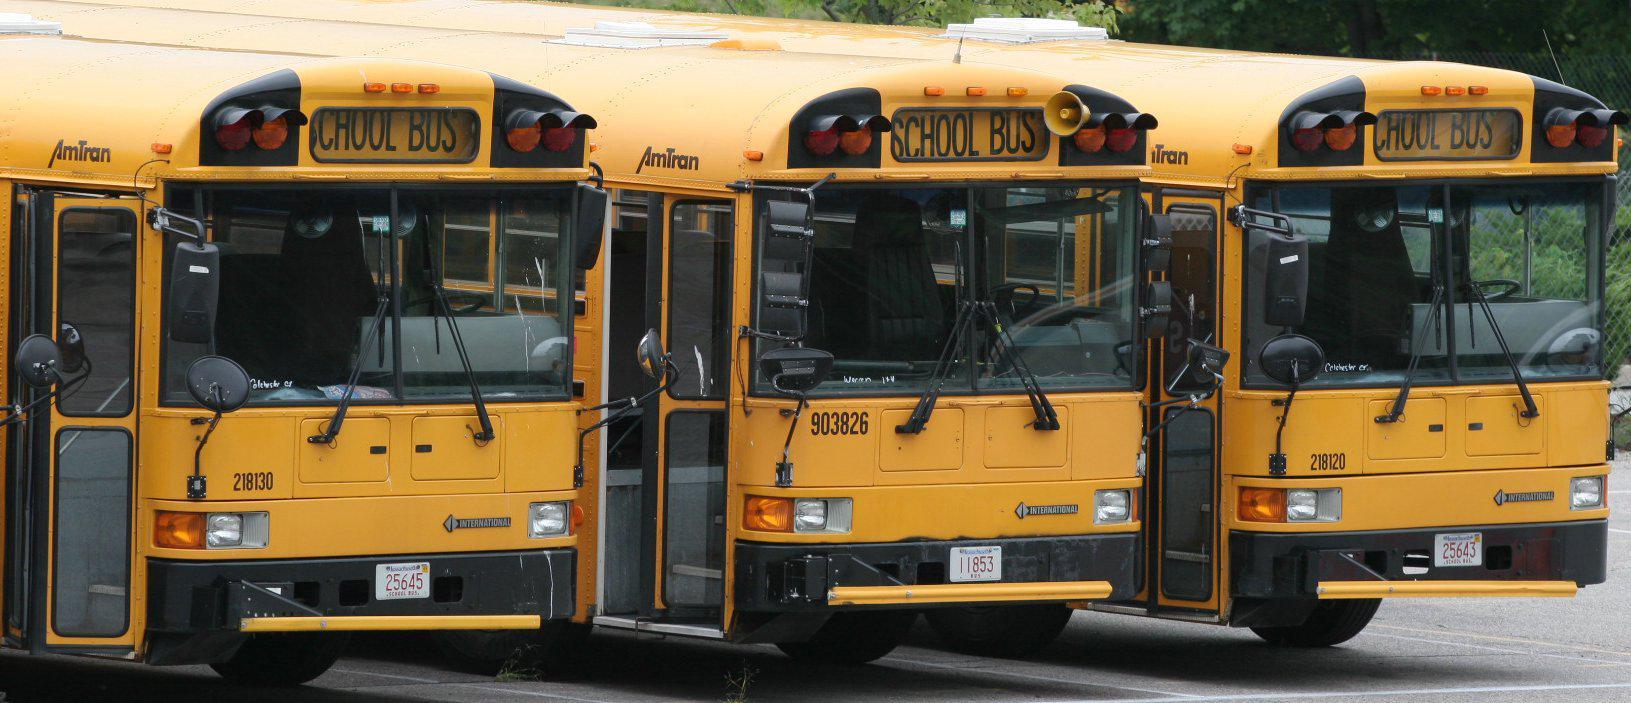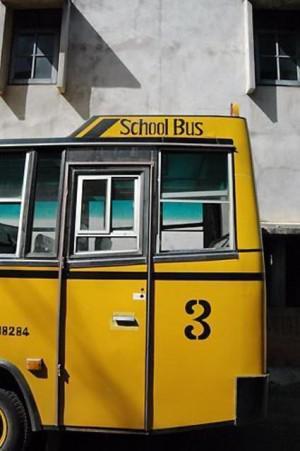The first image is the image on the left, the second image is the image on the right. Examine the images to the left and right. Is the description "There are two school buses in total." accurate? Answer yes or no. No. The first image is the image on the left, the second image is the image on the right. For the images displayed, is the sentence "Exactly two buses are visible." factually correct? Answer yes or no. No. 